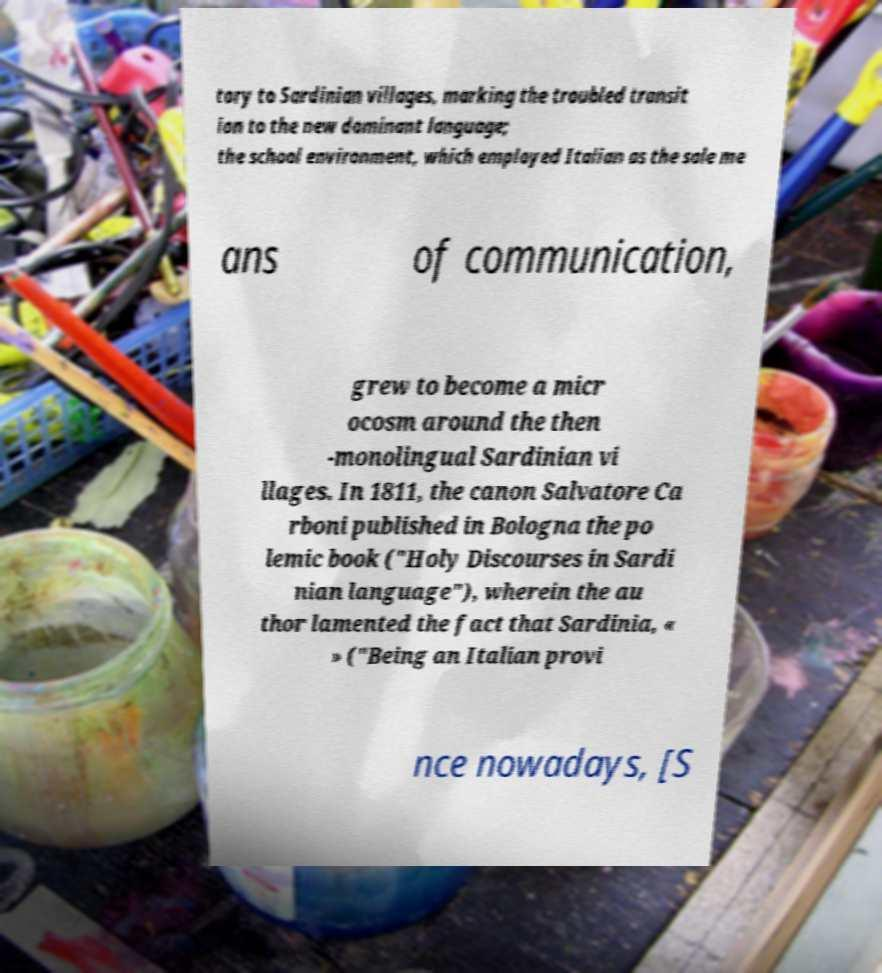What messages or text are displayed in this image? I need them in a readable, typed format. tory to Sardinian villages, marking the troubled transit ion to the new dominant language; the school environment, which employed Italian as the sole me ans of communication, grew to become a micr ocosm around the then -monolingual Sardinian vi llages. In 1811, the canon Salvatore Ca rboni published in Bologna the po lemic book ("Holy Discourses in Sardi nian language"), wherein the au thor lamented the fact that Sardinia, « » ("Being an Italian provi nce nowadays, [S 